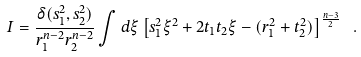<formula> <loc_0><loc_0><loc_500><loc_500>I = \frac { \delta ( s _ { 1 } ^ { 2 } , s _ { 2 } ^ { 2 } ) } { r _ { 1 } ^ { n - 2 } r _ { 2 } ^ { n - 2 } } \int d \xi \left [ s _ { 1 } ^ { 2 } \xi ^ { 2 } + 2 t _ { 1 } t _ { 2 } \xi - ( r _ { 1 } ^ { 2 } + t _ { 2 } ^ { 2 } ) \right ] ^ { \frac { n - 3 } { 2 } } \ .</formula> 